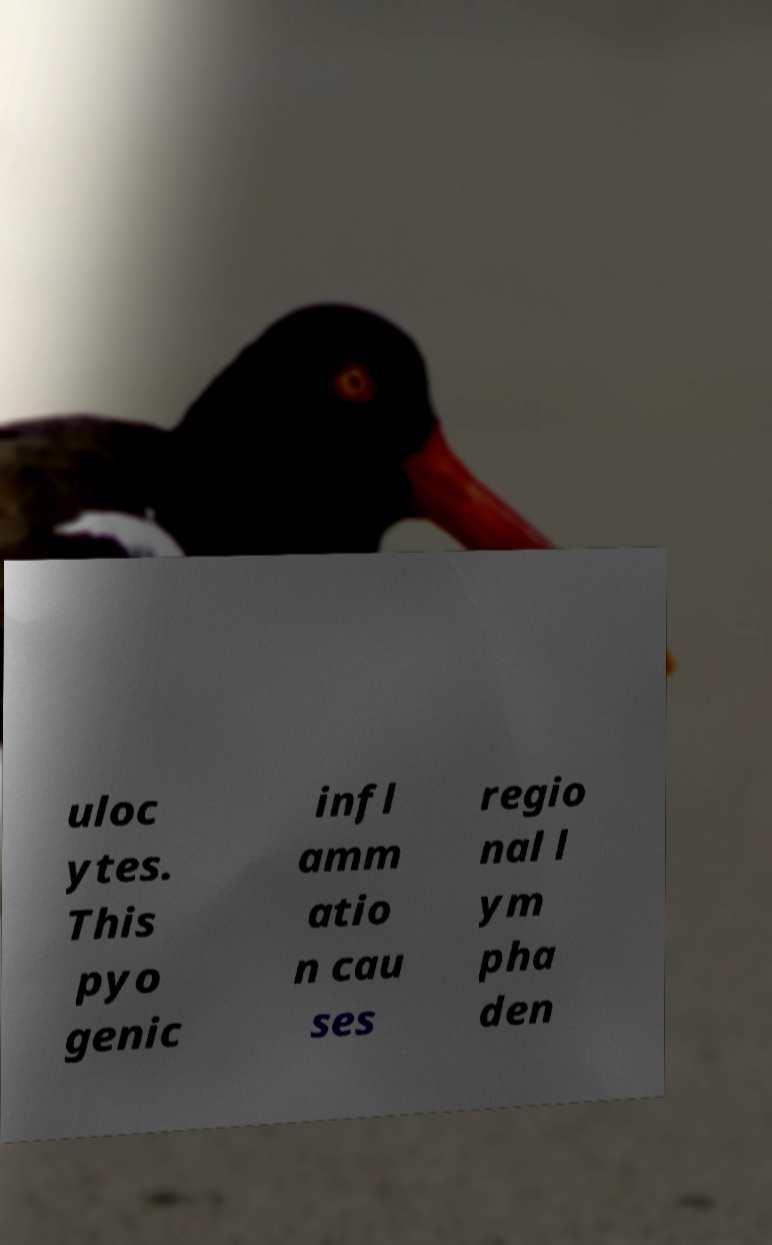There's text embedded in this image that I need extracted. Can you transcribe it verbatim? uloc ytes. This pyo genic infl amm atio n cau ses regio nal l ym pha den 